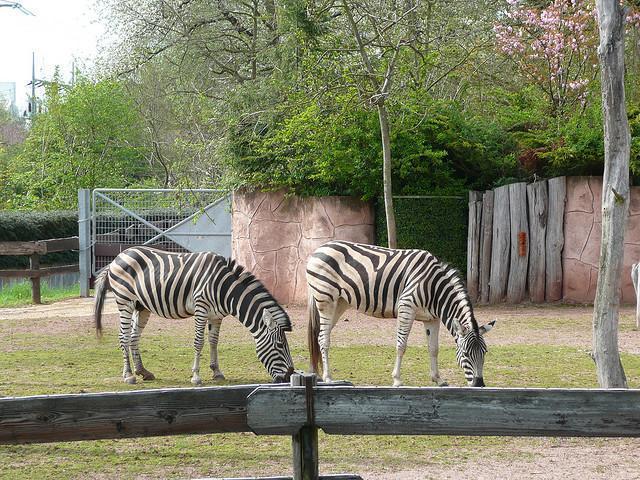How many zebras are there?
Give a very brief answer. 2. How many bears are in the picture?
Give a very brief answer. 0. 